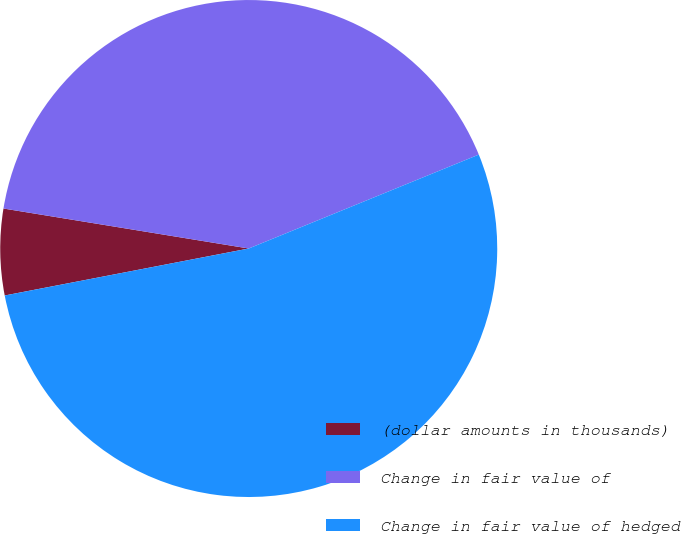<chart> <loc_0><loc_0><loc_500><loc_500><pie_chart><fcel>(dollar amounts in thousands)<fcel>Change in fair value of<fcel>Change in fair value of hedged<nl><fcel>5.6%<fcel>41.26%<fcel>53.14%<nl></chart> 